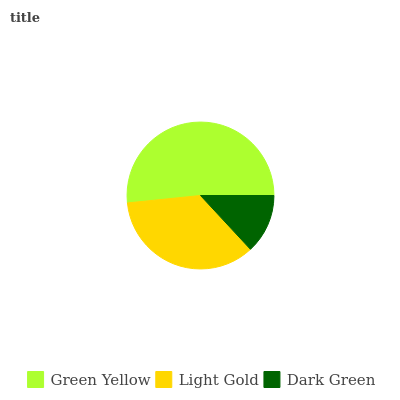Is Dark Green the minimum?
Answer yes or no. Yes. Is Green Yellow the maximum?
Answer yes or no. Yes. Is Light Gold the minimum?
Answer yes or no. No. Is Light Gold the maximum?
Answer yes or no. No. Is Green Yellow greater than Light Gold?
Answer yes or no. Yes. Is Light Gold less than Green Yellow?
Answer yes or no. Yes. Is Light Gold greater than Green Yellow?
Answer yes or no. No. Is Green Yellow less than Light Gold?
Answer yes or no. No. Is Light Gold the high median?
Answer yes or no. Yes. Is Light Gold the low median?
Answer yes or no. Yes. Is Dark Green the high median?
Answer yes or no. No. Is Green Yellow the low median?
Answer yes or no. No. 